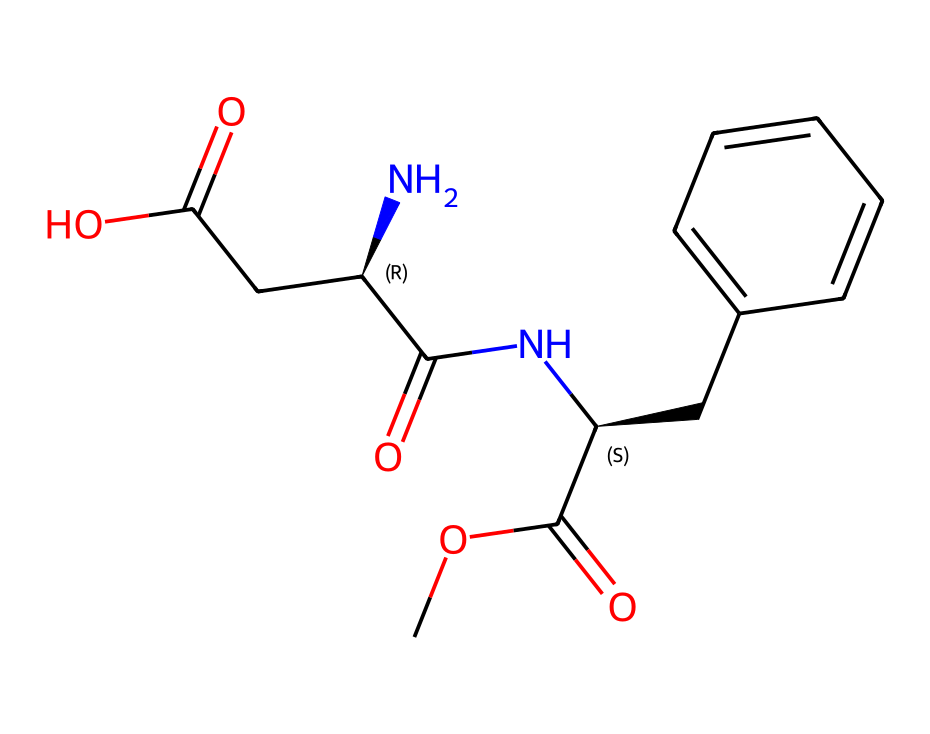How many carbon atoms are in aspartame? The SMILES representation shows multiple carbon atoms denoted by 'C'. By counting the 'C's in the structure, there are a total of 13 carbon atoms.
Answer: 13 What is the functional group indicated by 'C(=O)' in the structure? The notation 'C(=O)' represents a carbon atom double-bonded to an oxygen atom, which signifies a carbonyl group (found in ketones and aldehydes).
Answer: carbonyl How many chiral centers are present in aspartame? The 'C@' notations indicate chiral centers. By analyzing the structure, there are two 'C@'s, indicating that there are two chiral centers in the molecule.
Answer: 2 What is the significance of the chiral structure in aspartame? The chiral structure allows for different configurations, which can lead to varying biological activities and sensory effects, such as sweetness. The specific arrangement of atoms also affects its binding to taste receptors.
Answer: sweetness What type of amide is formed in the aspartame molecule? The amide functional group is represented by 'NC(=O)'. It is a primary amide as it is attached to a carbon that is either a carbonyl carbon or attached to a further carbon chain, confirming its classification as primary.
Answer: primary amide How many aromatic rings are present in the structure? The presence of 'C1=CC=CC=C1', which denotes an aromatic ring, indicates there is one aromatic ring within the aspartame structure.
Answer: 1 What type of compound is aspartame categorized as? Aspartame is characterized primarily as a non-nutritive sweetener, which falls under the category of artificial sweeteners due to its usage and structural properties.
Answer: artificial sweetener 